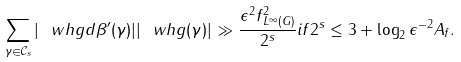<formula> <loc_0><loc_0><loc_500><loc_500>\sum _ { \gamma \in \mathcal { C } _ { s } } { | \ w h { g d \beta ^ { \prime } } ( \gamma ) | | \ w h { g } ( \gamma ) | } \gg \frac { \epsilon ^ { 2 } \| f \| _ { L ^ { \infty } ( G ) } ^ { 2 } } { 2 ^ { s } } i f 2 ^ { s } \leq 3 + \log _ { 2 } \epsilon ^ { - 2 } A _ { f } .</formula> 